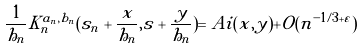<formula> <loc_0><loc_0><loc_500><loc_500>\frac { 1 } { h _ { n } } K _ { n } ^ { a _ { n } , b _ { n } } ( s _ { n } + \frac { x } { h _ { n } } , s + \frac { y } { h _ { n } } ) = A i ( x , y ) + O ( n ^ { - 1 / 3 + \varepsilon } )</formula> 